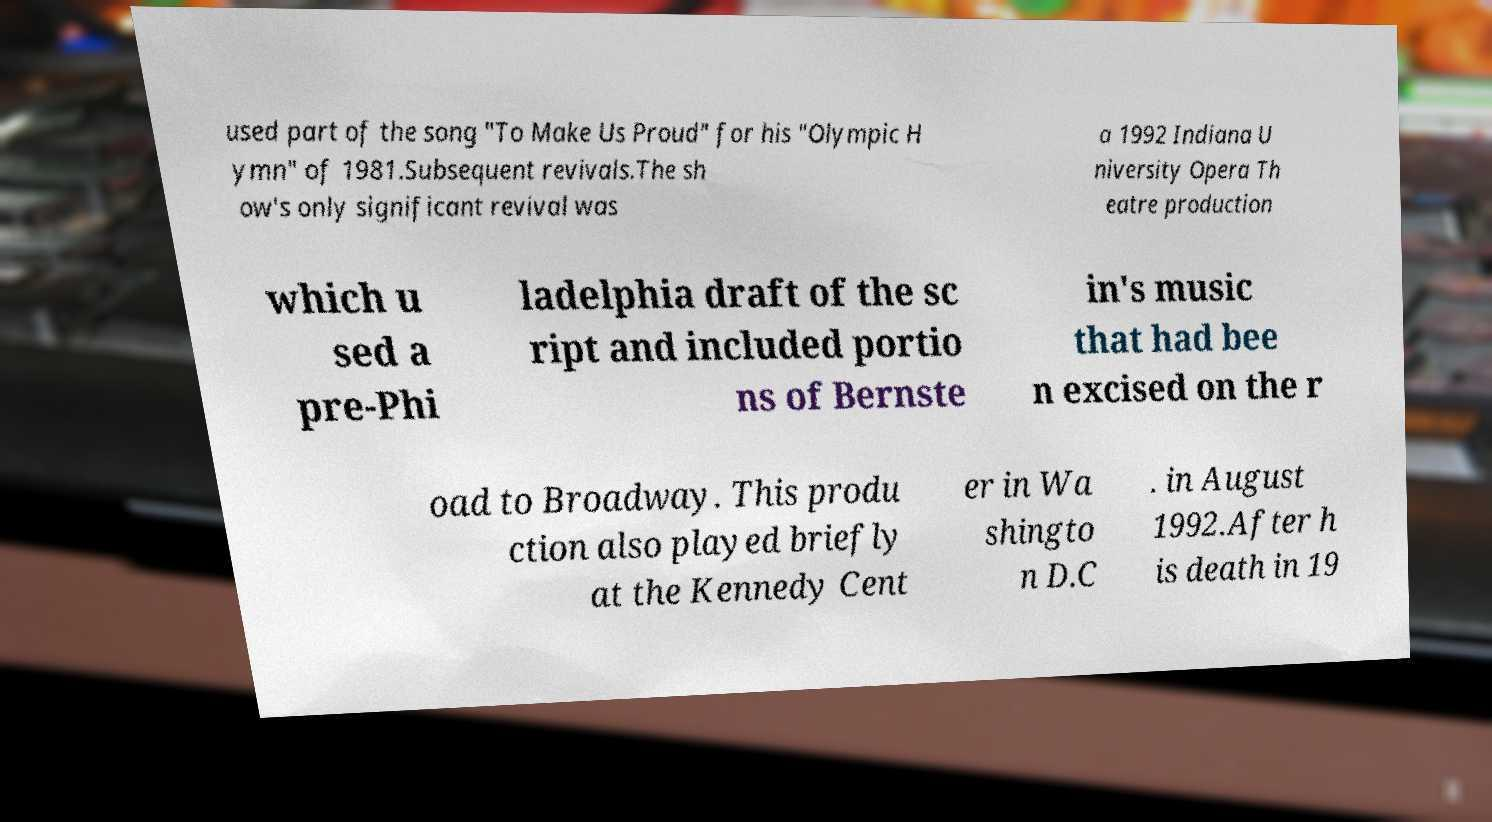What messages or text are displayed in this image? I need them in a readable, typed format. used part of the song "To Make Us Proud" for his "Olympic H ymn" of 1981.Subsequent revivals.The sh ow's only significant revival was a 1992 Indiana U niversity Opera Th eatre production which u sed a pre-Phi ladelphia draft of the sc ript and included portio ns of Bernste in's music that had bee n excised on the r oad to Broadway. This produ ction also played briefly at the Kennedy Cent er in Wa shingto n D.C . in August 1992.After h is death in 19 